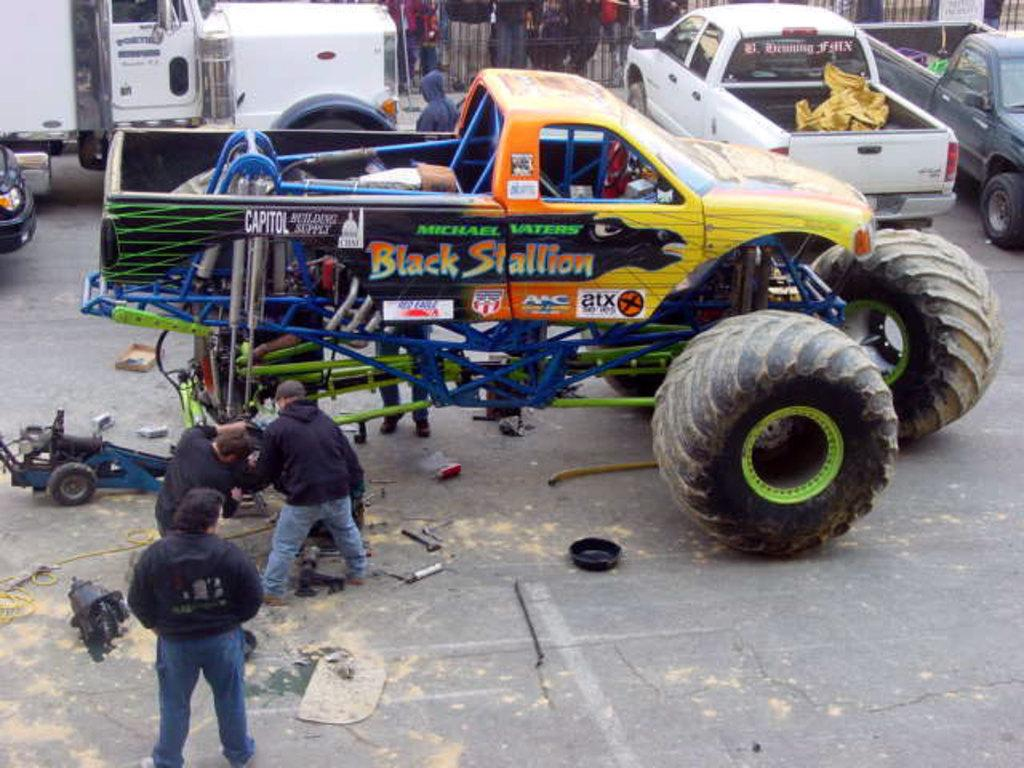Provide a one-sentence caption for the provided image. Men work on a pick up truck with huge oversized tires that is named the Black Stallion. 